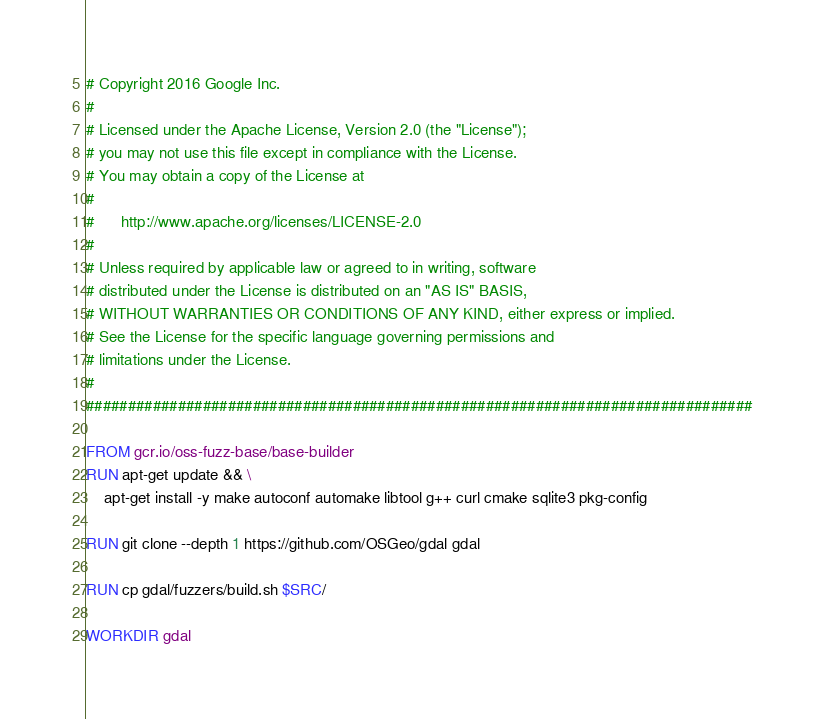Convert code to text. <code><loc_0><loc_0><loc_500><loc_500><_Dockerfile_># Copyright 2016 Google Inc.
#
# Licensed under the Apache License, Version 2.0 (the "License");
# you may not use this file except in compliance with the License.
# You may obtain a copy of the License at
#
#      http://www.apache.org/licenses/LICENSE-2.0
#
# Unless required by applicable law or agreed to in writing, software
# distributed under the License is distributed on an "AS IS" BASIS,
# WITHOUT WARRANTIES OR CONDITIONS OF ANY KIND, either express or implied.
# See the License for the specific language governing permissions and
# limitations under the License.
#
################################################################################

FROM gcr.io/oss-fuzz-base/base-builder
RUN apt-get update && \
    apt-get install -y make autoconf automake libtool g++ curl cmake sqlite3 pkg-config

RUN git clone --depth 1 https://github.com/OSGeo/gdal gdal

RUN cp gdal/fuzzers/build.sh $SRC/

WORKDIR gdal

</code> 